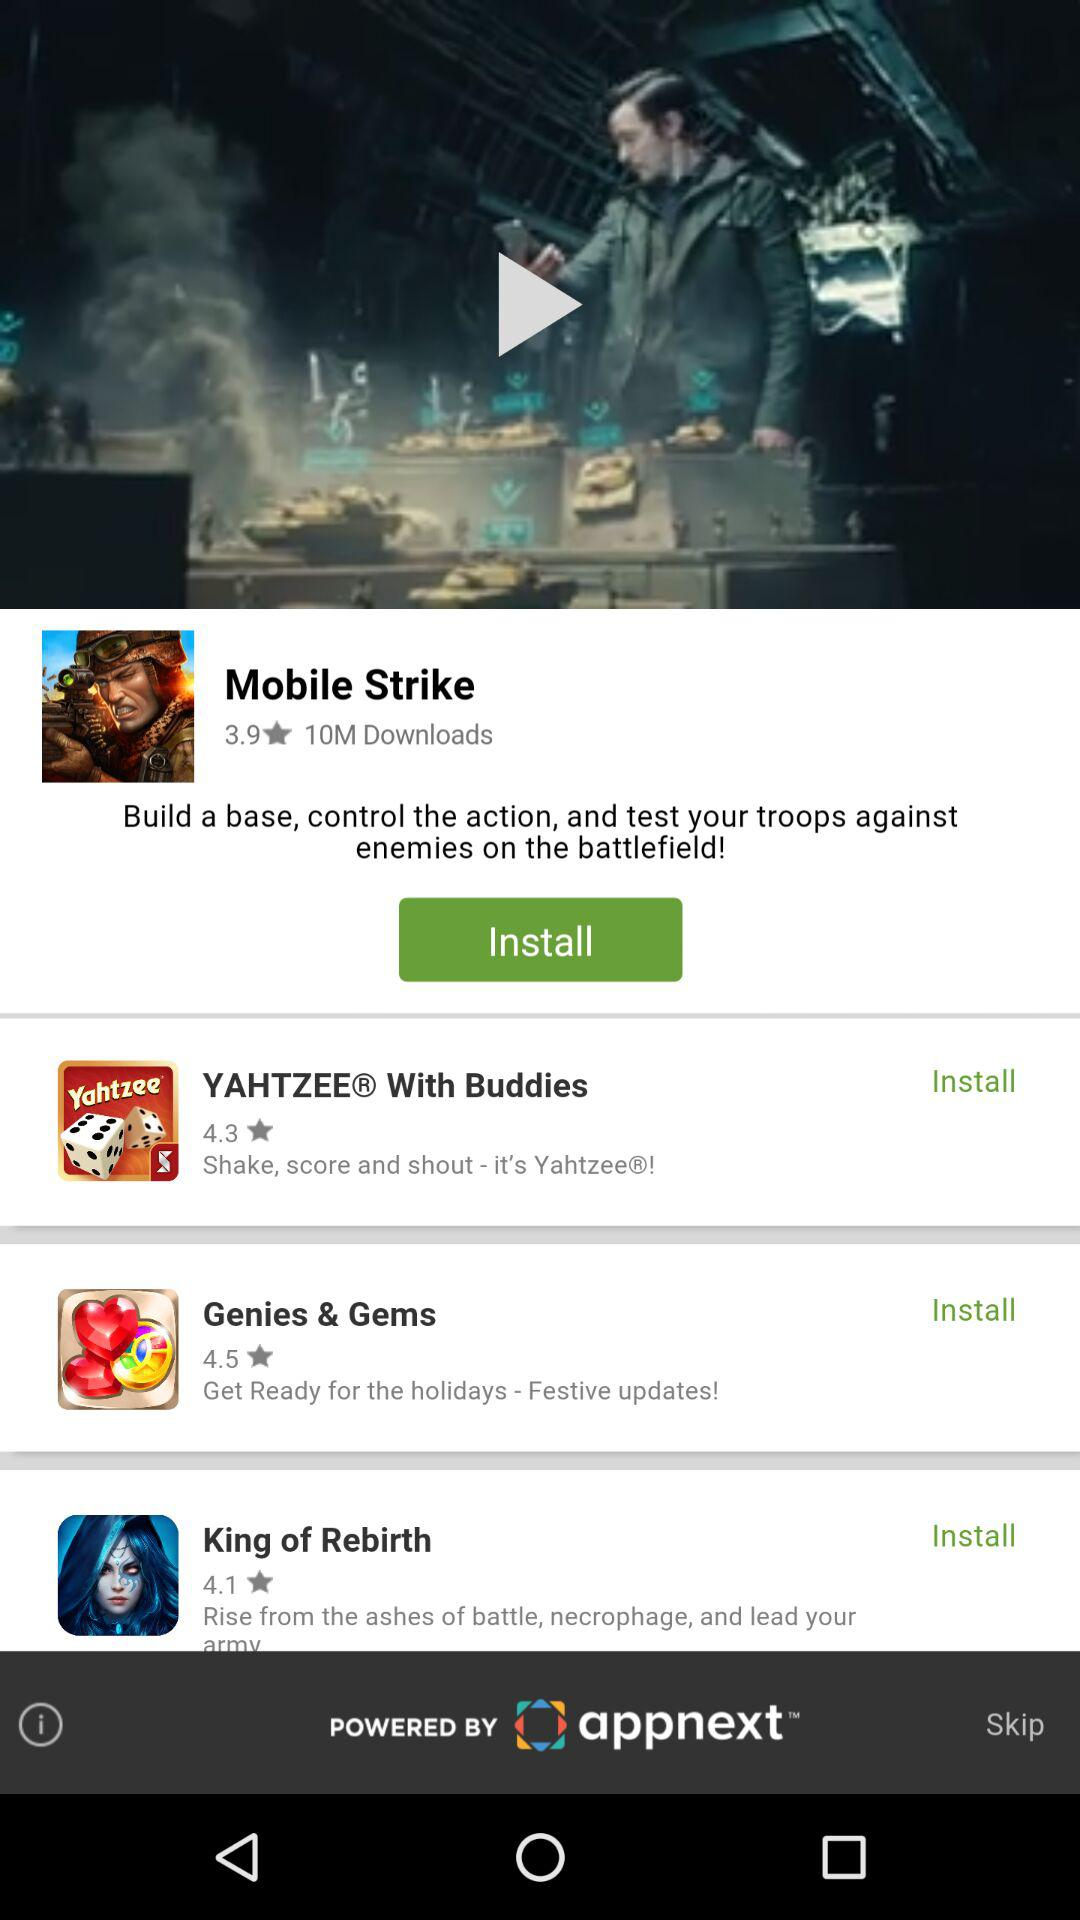What is the rating of "Mobile Strike"? The rating is 3.9 stars. 